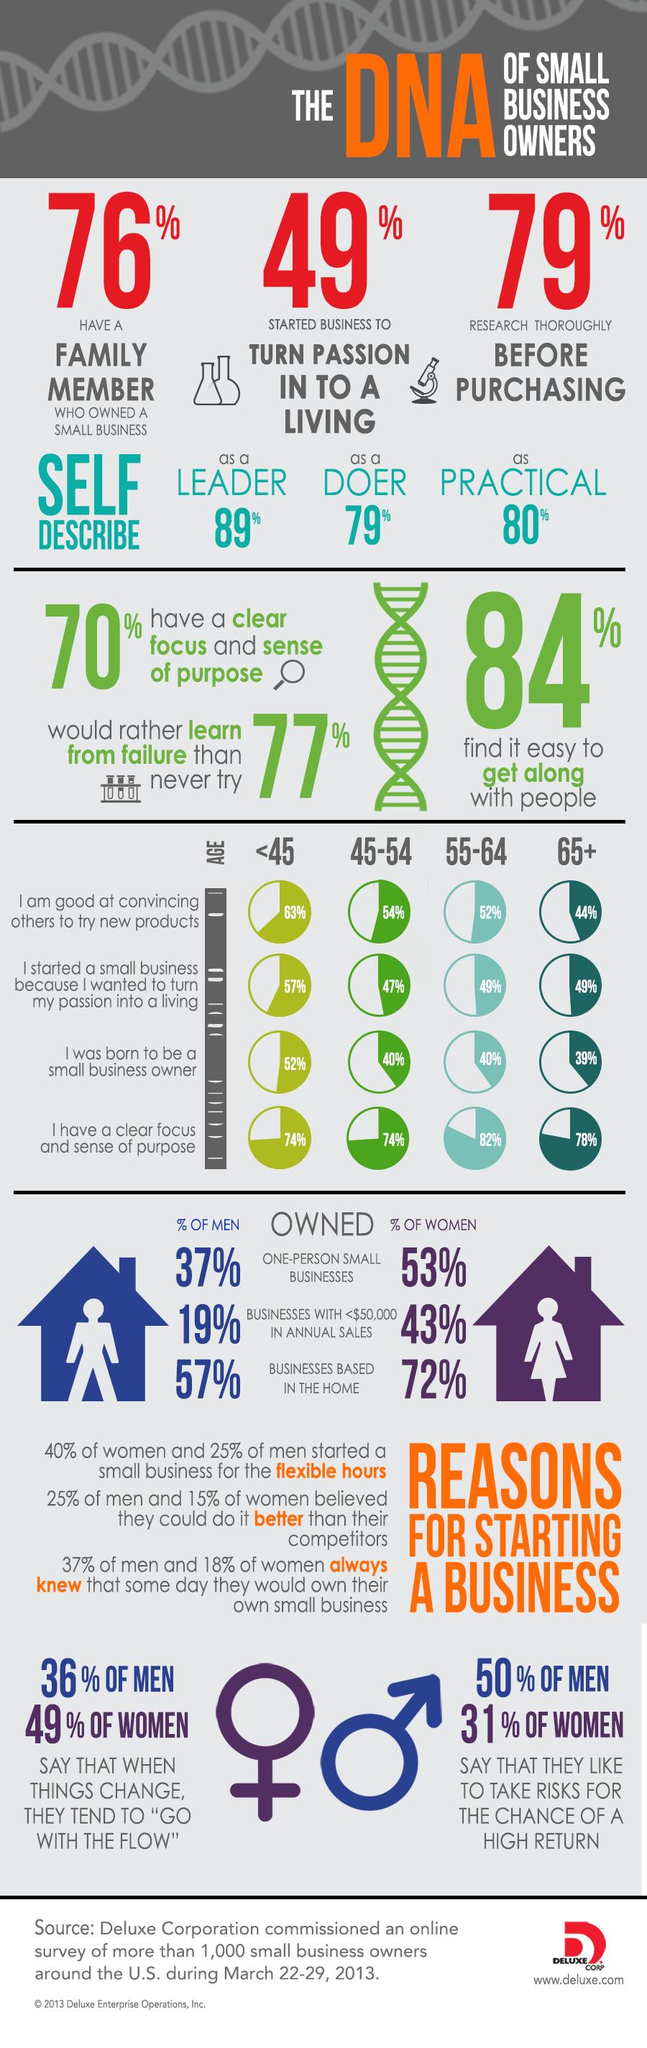Indicate a few pertinent items in this graphic. According to a survey, 44% of small business owners aged 65 and older in the U.S. believe that they are skilled at convincing others to try new products. According to the survey, 52% of small business owners under the age of 45 believe that they were born to be a small business owner. According to a survey, 50% of the men in the U.S. say that they enjoy taking risks for the possibility of a high return. According to a survey, 19% of men in the U.S. owned businesses with annual sales of less than $50,000. According to a survey, 72% of women in the U.S. own businesses that are based at home. 